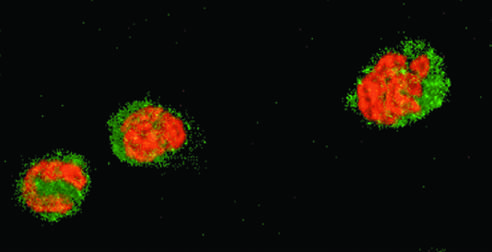two have lost whose nuclei?
Answer the question using a single word or phrase. Their 